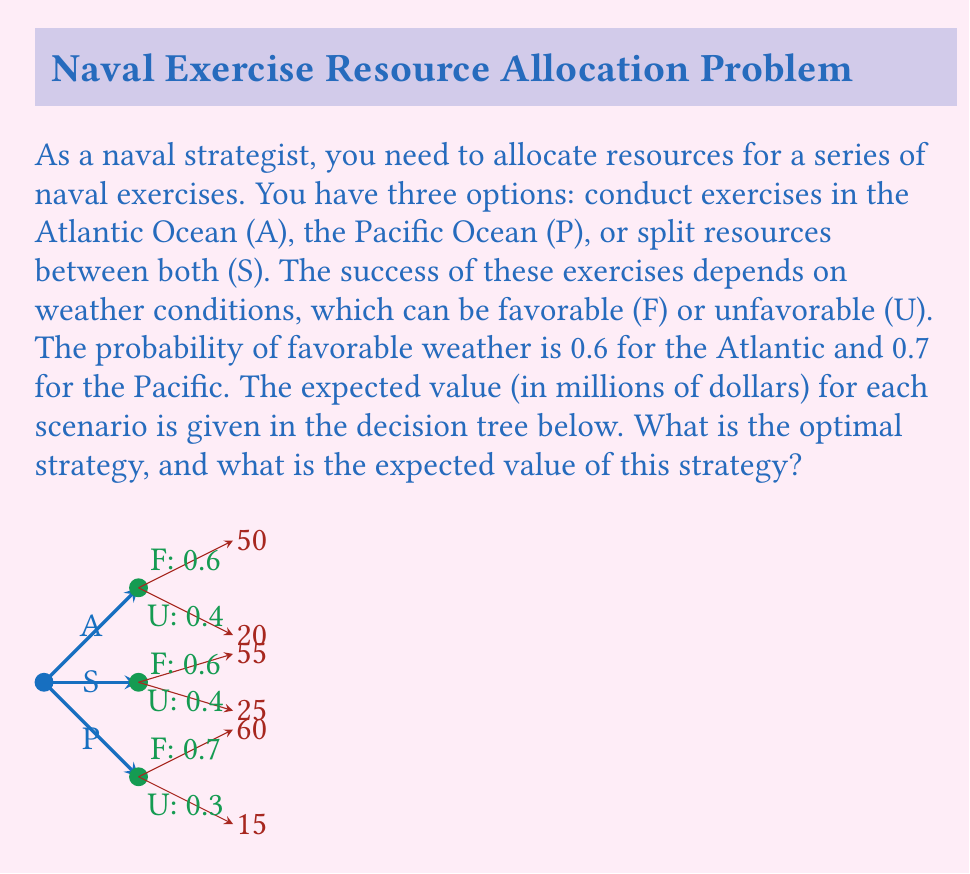Solve this math problem. To solve this problem, we need to calculate the expected value for each strategy using the decision tree and probability theory. Let's go through each option:

1. Atlantic Ocean (A):
   $$EV(A) = 0.6 \times 50 + 0.4 \times 20 = 30 + 8 = 38$$

2. Pacific Ocean (P):
   $$EV(P) = 0.7 \times 60 + 0.3 \times 15 = 42 + 4.5 = 46.5$$

3. Split resources (S):
   $$EV(S) = 0.6 \times 55 + 0.4 \times 25 = 33 + 10 = 43$$

Now, we compare the expected values:
$$EV(A) = 38 < EV(S) = 43 < EV(P) = 46.5$$

The optimal strategy is the one with the highest expected value, which is conducting exercises in the Pacific Ocean (P).

The expected value of this strategy is $46.5 million.
Answer: The optimal strategy is to conduct exercises in the Pacific Ocean (P), with an expected value of $46.5 million. 